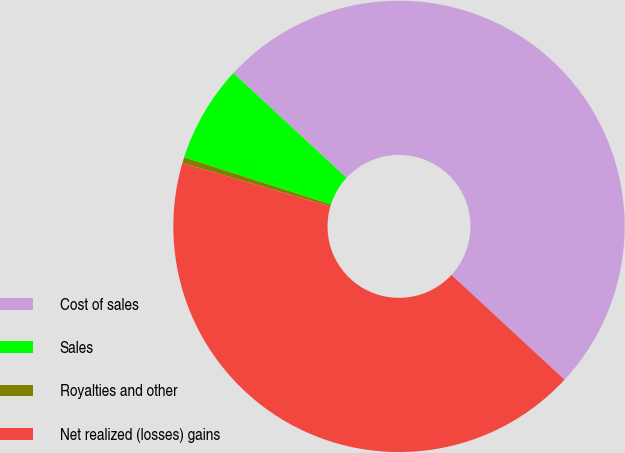Convert chart. <chart><loc_0><loc_0><loc_500><loc_500><pie_chart><fcel>Cost of sales<fcel>Sales<fcel>Royalties and other<fcel>Net realized (losses) gains<nl><fcel>50.0%<fcel>6.94%<fcel>0.43%<fcel>42.63%<nl></chart> 